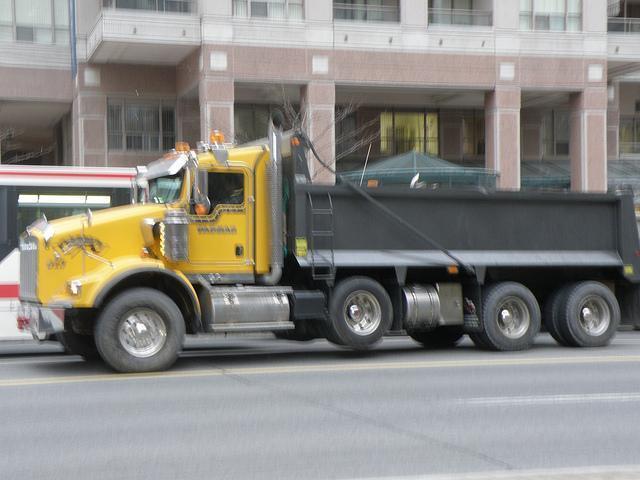How many tires do you see?
Give a very brief answer. 4. 